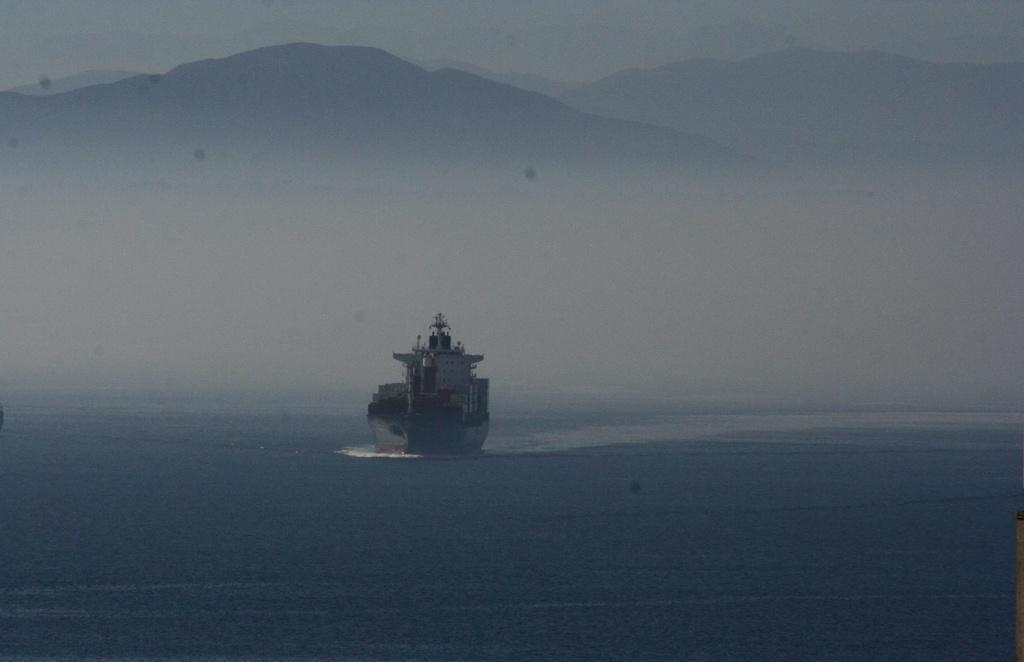What is the main subject of the image? There is a ship in the image. What is the ship doing in the image? The ship is sailing on the ocean. What type of landscape can be seen in the background of the image? There are hills visible at the top of the image. What type of sofa can be seen on the ship in the image? There is no sofa present on the ship in the image. Can you see someone wearing a vest on the ship in the image? There is no person wearing a vest visible on the ship in the image. 